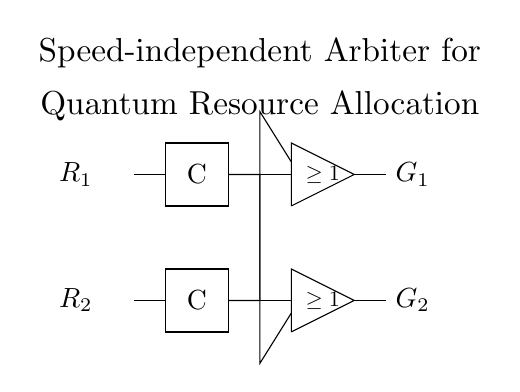What components are present in this circuit? The circuit contains two Muller C-elements and two NOR gates, which are the primary components used for managing signal synchronization and resource allocation.
Answer: Muller C-elements, NOR gates How many inputs are there in the circuit? There are two inputs labeled as R1 and R2, which are the entry points for the signals being processed by the circuit.
Answer: 2 What type of gate is used to determine the output conditions? The NOR gates are utilized to determine the output conditions based on input signals, specifically to check if at least one input is active.
Answer: NOR gates What is the purpose of the Muller C-elements in this circuit? The Muller C-elements function as signal storage elements that produce an output only when all inputs are stable and equal, ensuring synchronization in resource management.
Answer: Synchronization What condition do the NOR gates check for the output? The NOR gates check for the condition of having at least one active input signal, which allows for effective resource allocation based on the active inputs.
Answer: At least one active input What does the output G1 represent? The output G1 represents the signal that indicates the state of resource allocation based on the inputs processed by the associated logic elements.
Answer: Resource allocation state 